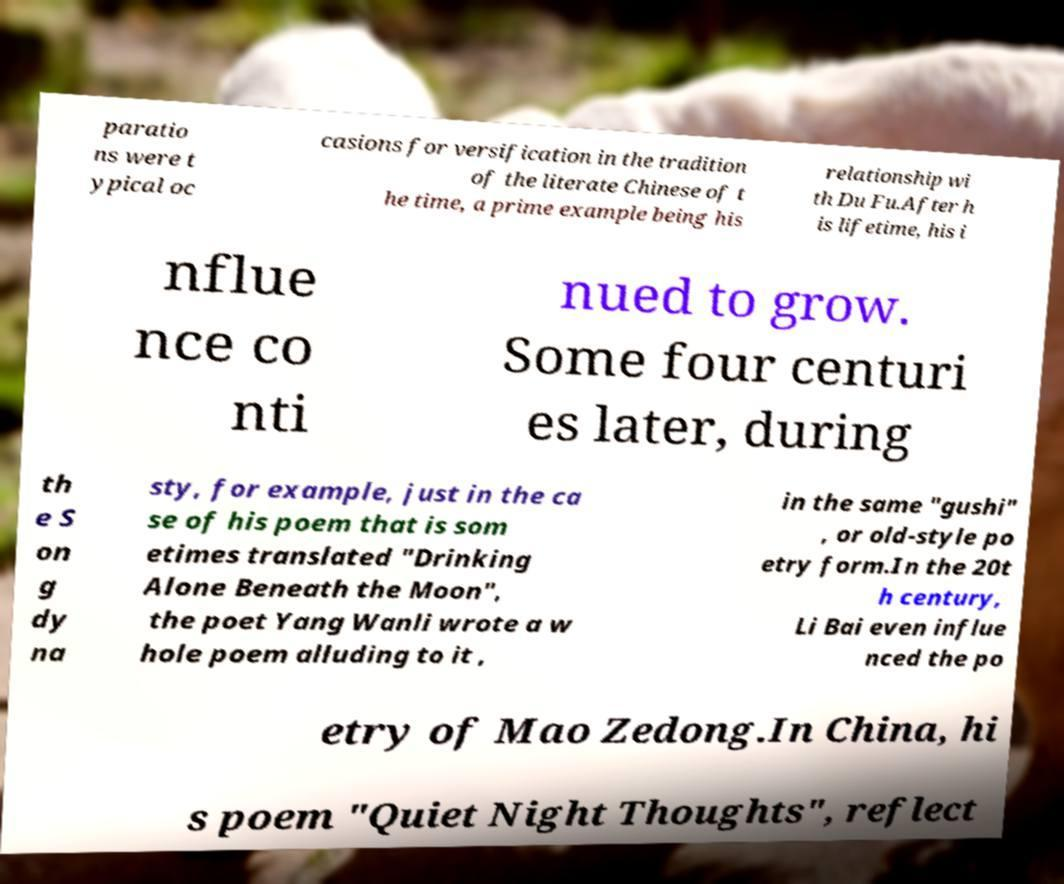Can you accurately transcribe the text from the provided image for me? paratio ns were t ypical oc casions for versification in the tradition of the literate Chinese of t he time, a prime example being his relationship wi th Du Fu.After h is lifetime, his i nflue nce co nti nued to grow. Some four centuri es later, during th e S on g dy na sty, for example, just in the ca se of his poem that is som etimes translated "Drinking Alone Beneath the Moon", the poet Yang Wanli wrote a w hole poem alluding to it , in the same "gushi" , or old-style po etry form.In the 20t h century, Li Bai even influe nced the po etry of Mao Zedong.In China, hi s poem "Quiet Night Thoughts", reflect 